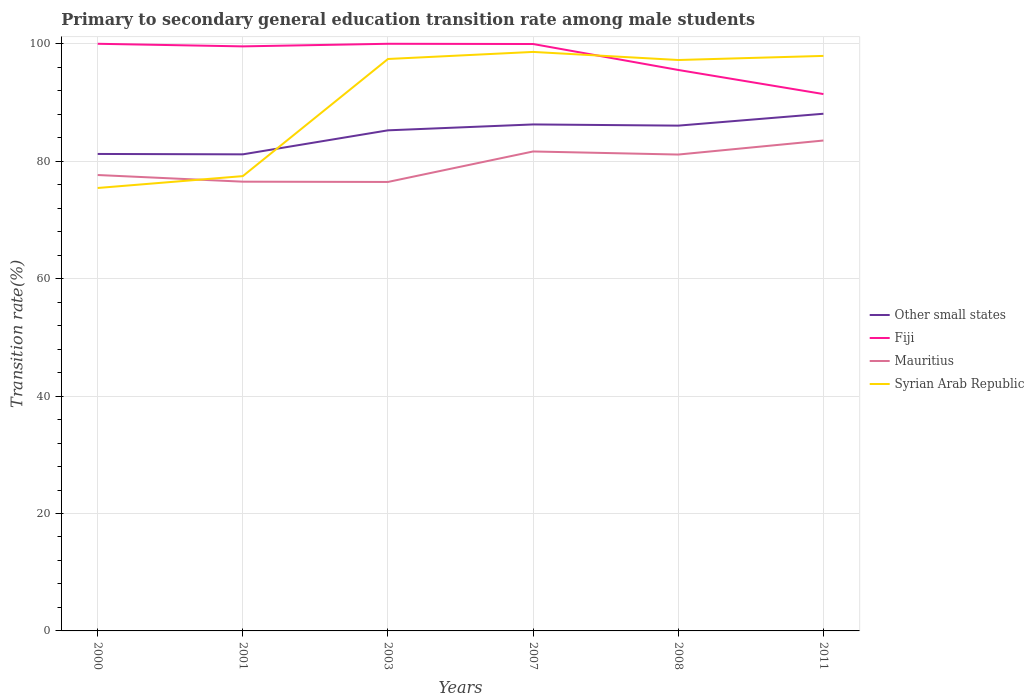How many different coloured lines are there?
Give a very brief answer. 4. Does the line corresponding to Fiji intersect with the line corresponding to Syrian Arab Republic?
Keep it short and to the point. Yes. Across all years, what is the maximum transition rate in Syrian Arab Republic?
Provide a short and direct response. 75.44. What is the difference between the highest and the second highest transition rate in Mauritius?
Keep it short and to the point. 7.06. What is the difference between the highest and the lowest transition rate in Syrian Arab Republic?
Provide a short and direct response. 4. How many lines are there?
Your answer should be compact. 4. What is the difference between two consecutive major ticks on the Y-axis?
Ensure brevity in your answer.  20. Are the values on the major ticks of Y-axis written in scientific E-notation?
Give a very brief answer. No. How many legend labels are there?
Your answer should be very brief. 4. How are the legend labels stacked?
Provide a succinct answer. Vertical. What is the title of the graph?
Your answer should be very brief. Primary to secondary general education transition rate among male students. What is the label or title of the X-axis?
Your answer should be very brief. Years. What is the label or title of the Y-axis?
Offer a very short reply. Transition rate(%). What is the Transition rate(%) of Other small states in 2000?
Offer a terse response. 81.24. What is the Transition rate(%) of Mauritius in 2000?
Your answer should be compact. 77.65. What is the Transition rate(%) in Syrian Arab Republic in 2000?
Offer a terse response. 75.44. What is the Transition rate(%) of Other small states in 2001?
Provide a short and direct response. 81.17. What is the Transition rate(%) in Fiji in 2001?
Provide a short and direct response. 99.56. What is the Transition rate(%) of Mauritius in 2001?
Make the answer very short. 76.51. What is the Transition rate(%) in Syrian Arab Republic in 2001?
Ensure brevity in your answer.  77.46. What is the Transition rate(%) in Other small states in 2003?
Make the answer very short. 85.26. What is the Transition rate(%) in Fiji in 2003?
Provide a short and direct response. 100. What is the Transition rate(%) of Mauritius in 2003?
Your answer should be very brief. 76.47. What is the Transition rate(%) in Syrian Arab Republic in 2003?
Your response must be concise. 97.41. What is the Transition rate(%) in Other small states in 2007?
Give a very brief answer. 86.26. What is the Transition rate(%) in Fiji in 2007?
Give a very brief answer. 99.96. What is the Transition rate(%) of Mauritius in 2007?
Your answer should be compact. 81.66. What is the Transition rate(%) in Syrian Arab Republic in 2007?
Give a very brief answer. 98.61. What is the Transition rate(%) of Other small states in 2008?
Provide a succinct answer. 86.06. What is the Transition rate(%) of Fiji in 2008?
Your answer should be very brief. 95.54. What is the Transition rate(%) of Mauritius in 2008?
Your answer should be compact. 81.13. What is the Transition rate(%) of Syrian Arab Republic in 2008?
Your answer should be compact. 97.24. What is the Transition rate(%) in Other small states in 2011?
Give a very brief answer. 88.09. What is the Transition rate(%) of Fiji in 2011?
Offer a very short reply. 91.44. What is the Transition rate(%) in Mauritius in 2011?
Your answer should be compact. 83.52. What is the Transition rate(%) in Syrian Arab Republic in 2011?
Give a very brief answer. 97.93. Across all years, what is the maximum Transition rate(%) in Other small states?
Provide a succinct answer. 88.09. Across all years, what is the maximum Transition rate(%) of Fiji?
Make the answer very short. 100. Across all years, what is the maximum Transition rate(%) in Mauritius?
Give a very brief answer. 83.52. Across all years, what is the maximum Transition rate(%) in Syrian Arab Republic?
Offer a very short reply. 98.61. Across all years, what is the minimum Transition rate(%) in Other small states?
Keep it short and to the point. 81.17. Across all years, what is the minimum Transition rate(%) in Fiji?
Keep it short and to the point. 91.44. Across all years, what is the minimum Transition rate(%) in Mauritius?
Provide a succinct answer. 76.47. Across all years, what is the minimum Transition rate(%) of Syrian Arab Republic?
Keep it short and to the point. 75.44. What is the total Transition rate(%) of Other small states in the graph?
Your answer should be very brief. 508.07. What is the total Transition rate(%) in Fiji in the graph?
Your answer should be very brief. 586.49. What is the total Transition rate(%) of Mauritius in the graph?
Your response must be concise. 476.95. What is the total Transition rate(%) in Syrian Arab Republic in the graph?
Offer a very short reply. 544.1. What is the difference between the Transition rate(%) of Other small states in 2000 and that in 2001?
Provide a short and direct response. 0.07. What is the difference between the Transition rate(%) in Fiji in 2000 and that in 2001?
Provide a succinct answer. 0.44. What is the difference between the Transition rate(%) in Mauritius in 2000 and that in 2001?
Your answer should be very brief. 1.14. What is the difference between the Transition rate(%) in Syrian Arab Republic in 2000 and that in 2001?
Offer a terse response. -2.02. What is the difference between the Transition rate(%) of Other small states in 2000 and that in 2003?
Give a very brief answer. -4.02. What is the difference between the Transition rate(%) in Mauritius in 2000 and that in 2003?
Your answer should be compact. 1.18. What is the difference between the Transition rate(%) of Syrian Arab Republic in 2000 and that in 2003?
Offer a very short reply. -21.97. What is the difference between the Transition rate(%) in Other small states in 2000 and that in 2007?
Offer a terse response. -5.03. What is the difference between the Transition rate(%) in Fiji in 2000 and that in 2007?
Your answer should be compact. 0.04. What is the difference between the Transition rate(%) in Mauritius in 2000 and that in 2007?
Provide a succinct answer. -4.01. What is the difference between the Transition rate(%) in Syrian Arab Republic in 2000 and that in 2007?
Offer a terse response. -23.17. What is the difference between the Transition rate(%) in Other small states in 2000 and that in 2008?
Make the answer very short. -4.82. What is the difference between the Transition rate(%) of Fiji in 2000 and that in 2008?
Offer a very short reply. 4.46. What is the difference between the Transition rate(%) of Mauritius in 2000 and that in 2008?
Your response must be concise. -3.48. What is the difference between the Transition rate(%) in Syrian Arab Republic in 2000 and that in 2008?
Your answer should be very brief. -21.8. What is the difference between the Transition rate(%) of Other small states in 2000 and that in 2011?
Provide a short and direct response. -6.85. What is the difference between the Transition rate(%) of Fiji in 2000 and that in 2011?
Keep it short and to the point. 8.56. What is the difference between the Transition rate(%) in Mauritius in 2000 and that in 2011?
Keep it short and to the point. -5.87. What is the difference between the Transition rate(%) in Syrian Arab Republic in 2000 and that in 2011?
Your response must be concise. -22.49. What is the difference between the Transition rate(%) of Other small states in 2001 and that in 2003?
Make the answer very short. -4.09. What is the difference between the Transition rate(%) of Fiji in 2001 and that in 2003?
Offer a terse response. -0.44. What is the difference between the Transition rate(%) of Mauritius in 2001 and that in 2003?
Provide a succinct answer. 0.05. What is the difference between the Transition rate(%) of Syrian Arab Republic in 2001 and that in 2003?
Your answer should be compact. -19.95. What is the difference between the Transition rate(%) in Other small states in 2001 and that in 2007?
Your answer should be compact. -5.09. What is the difference between the Transition rate(%) of Fiji in 2001 and that in 2007?
Provide a succinct answer. -0.4. What is the difference between the Transition rate(%) of Mauritius in 2001 and that in 2007?
Offer a terse response. -5.15. What is the difference between the Transition rate(%) of Syrian Arab Republic in 2001 and that in 2007?
Make the answer very short. -21.15. What is the difference between the Transition rate(%) in Other small states in 2001 and that in 2008?
Ensure brevity in your answer.  -4.89. What is the difference between the Transition rate(%) of Fiji in 2001 and that in 2008?
Keep it short and to the point. 4.02. What is the difference between the Transition rate(%) in Mauritius in 2001 and that in 2008?
Offer a very short reply. -4.62. What is the difference between the Transition rate(%) of Syrian Arab Republic in 2001 and that in 2008?
Keep it short and to the point. -19.78. What is the difference between the Transition rate(%) in Other small states in 2001 and that in 2011?
Ensure brevity in your answer.  -6.92. What is the difference between the Transition rate(%) of Fiji in 2001 and that in 2011?
Make the answer very short. 8.12. What is the difference between the Transition rate(%) of Mauritius in 2001 and that in 2011?
Your answer should be very brief. -7.01. What is the difference between the Transition rate(%) in Syrian Arab Republic in 2001 and that in 2011?
Offer a very short reply. -20.47. What is the difference between the Transition rate(%) of Other small states in 2003 and that in 2007?
Make the answer very short. -1. What is the difference between the Transition rate(%) in Fiji in 2003 and that in 2007?
Keep it short and to the point. 0.04. What is the difference between the Transition rate(%) of Mauritius in 2003 and that in 2007?
Ensure brevity in your answer.  -5.19. What is the difference between the Transition rate(%) in Syrian Arab Republic in 2003 and that in 2007?
Your answer should be very brief. -1.2. What is the difference between the Transition rate(%) of Other small states in 2003 and that in 2008?
Provide a succinct answer. -0.8. What is the difference between the Transition rate(%) in Fiji in 2003 and that in 2008?
Provide a short and direct response. 4.46. What is the difference between the Transition rate(%) in Mauritius in 2003 and that in 2008?
Offer a very short reply. -4.67. What is the difference between the Transition rate(%) in Syrian Arab Republic in 2003 and that in 2008?
Offer a very short reply. 0.17. What is the difference between the Transition rate(%) in Other small states in 2003 and that in 2011?
Provide a succinct answer. -2.82. What is the difference between the Transition rate(%) in Fiji in 2003 and that in 2011?
Provide a short and direct response. 8.56. What is the difference between the Transition rate(%) in Mauritius in 2003 and that in 2011?
Provide a short and direct response. -7.06. What is the difference between the Transition rate(%) in Syrian Arab Republic in 2003 and that in 2011?
Offer a very short reply. -0.52. What is the difference between the Transition rate(%) of Other small states in 2007 and that in 2008?
Give a very brief answer. 0.2. What is the difference between the Transition rate(%) of Fiji in 2007 and that in 2008?
Offer a terse response. 4.42. What is the difference between the Transition rate(%) in Mauritius in 2007 and that in 2008?
Ensure brevity in your answer.  0.53. What is the difference between the Transition rate(%) in Syrian Arab Republic in 2007 and that in 2008?
Make the answer very short. 1.38. What is the difference between the Transition rate(%) in Other small states in 2007 and that in 2011?
Provide a short and direct response. -1.82. What is the difference between the Transition rate(%) of Fiji in 2007 and that in 2011?
Your answer should be very brief. 8.52. What is the difference between the Transition rate(%) of Mauritius in 2007 and that in 2011?
Give a very brief answer. -1.86. What is the difference between the Transition rate(%) of Syrian Arab Republic in 2007 and that in 2011?
Keep it short and to the point. 0.68. What is the difference between the Transition rate(%) of Other small states in 2008 and that in 2011?
Provide a short and direct response. -2.02. What is the difference between the Transition rate(%) of Fiji in 2008 and that in 2011?
Keep it short and to the point. 4.1. What is the difference between the Transition rate(%) in Mauritius in 2008 and that in 2011?
Provide a succinct answer. -2.39. What is the difference between the Transition rate(%) in Syrian Arab Republic in 2008 and that in 2011?
Offer a very short reply. -0.7. What is the difference between the Transition rate(%) of Other small states in 2000 and the Transition rate(%) of Fiji in 2001?
Provide a succinct answer. -18.32. What is the difference between the Transition rate(%) in Other small states in 2000 and the Transition rate(%) in Mauritius in 2001?
Ensure brevity in your answer.  4.72. What is the difference between the Transition rate(%) in Other small states in 2000 and the Transition rate(%) in Syrian Arab Republic in 2001?
Your answer should be compact. 3.77. What is the difference between the Transition rate(%) of Fiji in 2000 and the Transition rate(%) of Mauritius in 2001?
Give a very brief answer. 23.49. What is the difference between the Transition rate(%) in Fiji in 2000 and the Transition rate(%) in Syrian Arab Republic in 2001?
Offer a very short reply. 22.54. What is the difference between the Transition rate(%) in Mauritius in 2000 and the Transition rate(%) in Syrian Arab Republic in 2001?
Offer a very short reply. 0.19. What is the difference between the Transition rate(%) of Other small states in 2000 and the Transition rate(%) of Fiji in 2003?
Make the answer very short. -18.76. What is the difference between the Transition rate(%) of Other small states in 2000 and the Transition rate(%) of Mauritius in 2003?
Make the answer very short. 4.77. What is the difference between the Transition rate(%) of Other small states in 2000 and the Transition rate(%) of Syrian Arab Republic in 2003?
Keep it short and to the point. -16.17. What is the difference between the Transition rate(%) in Fiji in 2000 and the Transition rate(%) in Mauritius in 2003?
Make the answer very short. 23.53. What is the difference between the Transition rate(%) of Fiji in 2000 and the Transition rate(%) of Syrian Arab Republic in 2003?
Provide a short and direct response. 2.59. What is the difference between the Transition rate(%) in Mauritius in 2000 and the Transition rate(%) in Syrian Arab Republic in 2003?
Provide a short and direct response. -19.76. What is the difference between the Transition rate(%) in Other small states in 2000 and the Transition rate(%) in Fiji in 2007?
Your response must be concise. -18.72. What is the difference between the Transition rate(%) in Other small states in 2000 and the Transition rate(%) in Mauritius in 2007?
Keep it short and to the point. -0.42. What is the difference between the Transition rate(%) in Other small states in 2000 and the Transition rate(%) in Syrian Arab Republic in 2007?
Ensure brevity in your answer.  -17.38. What is the difference between the Transition rate(%) in Fiji in 2000 and the Transition rate(%) in Mauritius in 2007?
Ensure brevity in your answer.  18.34. What is the difference between the Transition rate(%) of Fiji in 2000 and the Transition rate(%) of Syrian Arab Republic in 2007?
Ensure brevity in your answer.  1.39. What is the difference between the Transition rate(%) in Mauritius in 2000 and the Transition rate(%) in Syrian Arab Republic in 2007?
Give a very brief answer. -20.96. What is the difference between the Transition rate(%) of Other small states in 2000 and the Transition rate(%) of Fiji in 2008?
Your response must be concise. -14.3. What is the difference between the Transition rate(%) of Other small states in 2000 and the Transition rate(%) of Mauritius in 2008?
Give a very brief answer. 0.1. What is the difference between the Transition rate(%) of Other small states in 2000 and the Transition rate(%) of Syrian Arab Republic in 2008?
Give a very brief answer. -16. What is the difference between the Transition rate(%) in Fiji in 2000 and the Transition rate(%) in Mauritius in 2008?
Ensure brevity in your answer.  18.87. What is the difference between the Transition rate(%) in Fiji in 2000 and the Transition rate(%) in Syrian Arab Republic in 2008?
Your response must be concise. 2.76. What is the difference between the Transition rate(%) in Mauritius in 2000 and the Transition rate(%) in Syrian Arab Republic in 2008?
Provide a succinct answer. -19.59. What is the difference between the Transition rate(%) of Other small states in 2000 and the Transition rate(%) of Fiji in 2011?
Your answer should be compact. -10.2. What is the difference between the Transition rate(%) in Other small states in 2000 and the Transition rate(%) in Mauritius in 2011?
Provide a short and direct response. -2.29. What is the difference between the Transition rate(%) in Other small states in 2000 and the Transition rate(%) in Syrian Arab Republic in 2011?
Your answer should be compact. -16.7. What is the difference between the Transition rate(%) in Fiji in 2000 and the Transition rate(%) in Mauritius in 2011?
Offer a very short reply. 16.48. What is the difference between the Transition rate(%) in Fiji in 2000 and the Transition rate(%) in Syrian Arab Republic in 2011?
Ensure brevity in your answer.  2.07. What is the difference between the Transition rate(%) of Mauritius in 2000 and the Transition rate(%) of Syrian Arab Republic in 2011?
Your answer should be compact. -20.29. What is the difference between the Transition rate(%) in Other small states in 2001 and the Transition rate(%) in Fiji in 2003?
Offer a very short reply. -18.83. What is the difference between the Transition rate(%) of Other small states in 2001 and the Transition rate(%) of Mauritius in 2003?
Provide a short and direct response. 4.7. What is the difference between the Transition rate(%) of Other small states in 2001 and the Transition rate(%) of Syrian Arab Republic in 2003?
Provide a succinct answer. -16.24. What is the difference between the Transition rate(%) of Fiji in 2001 and the Transition rate(%) of Mauritius in 2003?
Your answer should be compact. 23.09. What is the difference between the Transition rate(%) in Fiji in 2001 and the Transition rate(%) in Syrian Arab Republic in 2003?
Ensure brevity in your answer.  2.15. What is the difference between the Transition rate(%) of Mauritius in 2001 and the Transition rate(%) of Syrian Arab Republic in 2003?
Provide a short and direct response. -20.9. What is the difference between the Transition rate(%) in Other small states in 2001 and the Transition rate(%) in Fiji in 2007?
Ensure brevity in your answer.  -18.79. What is the difference between the Transition rate(%) of Other small states in 2001 and the Transition rate(%) of Mauritius in 2007?
Your answer should be very brief. -0.49. What is the difference between the Transition rate(%) of Other small states in 2001 and the Transition rate(%) of Syrian Arab Republic in 2007?
Offer a very short reply. -17.45. What is the difference between the Transition rate(%) in Fiji in 2001 and the Transition rate(%) in Mauritius in 2007?
Provide a succinct answer. 17.9. What is the difference between the Transition rate(%) in Fiji in 2001 and the Transition rate(%) in Syrian Arab Republic in 2007?
Provide a short and direct response. 0.94. What is the difference between the Transition rate(%) in Mauritius in 2001 and the Transition rate(%) in Syrian Arab Republic in 2007?
Ensure brevity in your answer.  -22.1. What is the difference between the Transition rate(%) of Other small states in 2001 and the Transition rate(%) of Fiji in 2008?
Offer a terse response. -14.37. What is the difference between the Transition rate(%) in Other small states in 2001 and the Transition rate(%) in Mauritius in 2008?
Ensure brevity in your answer.  0.04. What is the difference between the Transition rate(%) in Other small states in 2001 and the Transition rate(%) in Syrian Arab Republic in 2008?
Keep it short and to the point. -16.07. What is the difference between the Transition rate(%) of Fiji in 2001 and the Transition rate(%) of Mauritius in 2008?
Make the answer very short. 18.42. What is the difference between the Transition rate(%) of Fiji in 2001 and the Transition rate(%) of Syrian Arab Republic in 2008?
Keep it short and to the point. 2.32. What is the difference between the Transition rate(%) in Mauritius in 2001 and the Transition rate(%) in Syrian Arab Republic in 2008?
Provide a short and direct response. -20.72. What is the difference between the Transition rate(%) of Other small states in 2001 and the Transition rate(%) of Fiji in 2011?
Give a very brief answer. -10.27. What is the difference between the Transition rate(%) in Other small states in 2001 and the Transition rate(%) in Mauritius in 2011?
Your response must be concise. -2.35. What is the difference between the Transition rate(%) of Other small states in 2001 and the Transition rate(%) of Syrian Arab Republic in 2011?
Provide a succinct answer. -16.77. What is the difference between the Transition rate(%) in Fiji in 2001 and the Transition rate(%) in Mauritius in 2011?
Ensure brevity in your answer.  16.03. What is the difference between the Transition rate(%) in Fiji in 2001 and the Transition rate(%) in Syrian Arab Republic in 2011?
Provide a succinct answer. 1.62. What is the difference between the Transition rate(%) in Mauritius in 2001 and the Transition rate(%) in Syrian Arab Republic in 2011?
Offer a very short reply. -21.42. What is the difference between the Transition rate(%) in Other small states in 2003 and the Transition rate(%) in Fiji in 2007?
Your response must be concise. -14.7. What is the difference between the Transition rate(%) in Other small states in 2003 and the Transition rate(%) in Mauritius in 2007?
Your answer should be compact. 3.6. What is the difference between the Transition rate(%) in Other small states in 2003 and the Transition rate(%) in Syrian Arab Republic in 2007?
Give a very brief answer. -13.35. What is the difference between the Transition rate(%) in Fiji in 2003 and the Transition rate(%) in Mauritius in 2007?
Provide a short and direct response. 18.34. What is the difference between the Transition rate(%) in Fiji in 2003 and the Transition rate(%) in Syrian Arab Republic in 2007?
Your answer should be very brief. 1.39. What is the difference between the Transition rate(%) of Mauritius in 2003 and the Transition rate(%) of Syrian Arab Republic in 2007?
Make the answer very short. -22.15. What is the difference between the Transition rate(%) in Other small states in 2003 and the Transition rate(%) in Fiji in 2008?
Provide a short and direct response. -10.28. What is the difference between the Transition rate(%) of Other small states in 2003 and the Transition rate(%) of Mauritius in 2008?
Offer a terse response. 4.13. What is the difference between the Transition rate(%) of Other small states in 2003 and the Transition rate(%) of Syrian Arab Republic in 2008?
Provide a short and direct response. -11.98. What is the difference between the Transition rate(%) in Fiji in 2003 and the Transition rate(%) in Mauritius in 2008?
Ensure brevity in your answer.  18.87. What is the difference between the Transition rate(%) in Fiji in 2003 and the Transition rate(%) in Syrian Arab Republic in 2008?
Provide a short and direct response. 2.76. What is the difference between the Transition rate(%) of Mauritius in 2003 and the Transition rate(%) of Syrian Arab Republic in 2008?
Keep it short and to the point. -20.77. What is the difference between the Transition rate(%) in Other small states in 2003 and the Transition rate(%) in Fiji in 2011?
Provide a succinct answer. -6.18. What is the difference between the Transition rate(%) of Other small states in 2003 and the Transition rate(%) of Mauritius in 2011?
Give a very brief answer. 1.74. What is the difference between the Transition rate(%) of Other small states in 2003 and the Transition rate(%) of Syrian Arab Republic in 2011?
Keep it short and to the point. -12.67. What is the difference between the Transition rate(%) in Fiji in 2003 and the Transition rate(%) in Mauritius in 2011?
Make the answer very short. 16.48. What is the difference between the Transition rate(%) of Fiji in 2003 and the Transition rate(%) of Syrian Arab Republic in 2011?
Ensure brevity in your answer.  2.07. What is the difference between the Transition rate(%) of Mauritius in 2003 and the Transition rate(%) of Syrian Arab Republic in 2011?
Make the answer very short. -21.47. What is the difference between the Transition rate(%) in Other small states in 2007 and the Transition rate(%) in Fiji in 2008?
Your answer should be very brief. -9.28. What is the difference between the Transition rate(%) in Other small states in 2007 and the Transition rate(%) in Mauritius in 2008?
Provide a succinct answer. 5.13. What is the difference between the Transition rate(%) in Other small states in 2007 and the Transition rate(%) in Syrian Arab Republic in 2008?
Make the answer very short. -10.98. What is the difference between the Transition rate(%) of Fiji in 2007 and the Transition rate(%) of Mauritius in 2008?
Make the answer very short. 18.83. What is the difference between the Transition rate(%) of Fiji in 2007 and the Transition rate(%) of Syrian Arab Republic in 2008?
Provide a short and direct response. 2.72. What is the difference between the Transition rate(%) in Mauritius in 2007 and the Transition rate(%) in Syrian Arab Republic in 2008?
Ensure brevity in your answer.  -15.58. What is the difference between the Transition rate(%) in Other small states in 2007 and the Transition rate(%) in Fiji in 2011?
Ensure brevity in your answer.  -5.17. What is the difference between the Transition rate(%) in Other small states in 2007 and the Transition rate(%) in Mauritius in 2011?
Offer a very short reply. 2.74. What is the difference between the Transition rate(%) of Other small states in 2007 and the Transition rate(%) of Syrian Arab Republic in 2011?
Ensure brevity in your answer.  -11.67. What is the difference between the Transition rate(%) of Fiji in 2007 and the Transition rate(%) of Mauritius in 2011?
Keep it short and to the point. 16.44. What is the difference between the Transition rate(%) of Fiji in 2007 and the Transition rate(%) of Syrian Arab Republic in 2011?
Provide a succinct answer. 2.03. What is the difference between the Transition rate(%) in Mauritius in 2007 and the Transition rate(%) in Syrian Arab Republic in 2011?
Offer a terse response. -16.27. What is the difference between the Transition rate(%) of Other small states in 2008 and the Transition rate(%) of Fiji in 2011?
Keep it short and to the point. -5.38. What is the difference between the Transition rate(%) of Other small states in 2008 and the Transition rate(%) of Mauritius in 2011?
Offer a terse response. 2.54. What is the difference between the Transition rate(%) of Other small states in 2008 and the Transition rate(%) of Syrian Arab Republic in 2011?
Provide a succinct answer. -11.87. What is the difference between the Transition rate(%) of Fiji in 2008 and the Transition rate(%) of Mauritius in 2011?
Your answer should be compact. 12.02. What is the difference between the Transition rate(%) in Fiji in 2008 and the Transition rate(%) in Syrian Arab Republic in 2011?
Offer a very short reply. -2.39. What is the difference between the Transition rate(%) of Mauritius in 2008 and the Transition rate(%) of Syrian Arab Republic in 2011?
Offer a terse response. -16.8. What is the average Transition rate(%) in Other small states per year?
Give a very brief answer. 84.68. What is the average Transition rate(%) in Fiji per year?
Your response must be concise. 97.75. What is the average Transition rate(%) in Mauritius per year?
Keep it short and to the point. 79.49. What is the average Transition rate(%) in Syrian Arab Republic per year?
Your response must be concise. 90.68. In the year 2000, what is the difference between the Transition rate(%) in Other small states and Transition rate(%) in Fiji?
Provide a succinct answer. -18.76. In the year 2000, what is the difference between the Transition rate(%) of Other small states and Transition rate(%) of Mauritius?
Provide a short and direct response. 3.59. In the year 2000, what is the difference between the Transition rate(%) of Other small states and Transition rate(%) of Syrian Arab Republic?
Keep it short and to the point. 5.8. In the year 2000, what is the difference between the Transition rate(%) of Fiji and Transition rate(%) of Mauritius?
Offer a very short reply. 22.35. In the year 2000, what is the difference between the Transition rate(%) in Fiji and Transition rate(%) in Syrian Arab Republic?
Your answer should be compact. 24.56. In the year 2000, what is the difference between the Transition rate(%) in Mauritius and Transition rate(%) in Syrian Arab Republic?
Ensure brevity in your answer.  2.21. In the year 2001, what is the difference between the Transition rate(%) in Other small states and Transition rate(%) in Fiji?
Keep it short and to the point. -18.39. In the year 2001, what is the difference between the Transition rate(%) in Other small states and Transition rate(%) in Mauritius?
Keep it short and to the point. 4.65. In the year 2001, what is the difference between the Transition rate(%) of Other small states and Transition rate(%) of Syrian Arab Republic?
Provide a succinct answer. 3.71. In the year 2001, what is the difference between the Transition rate(%) of Fiji and Transition rate(%) of Mauritius?
Provide a succinct answer. 23.04. In the year 2001, what is the difference between the Transition rate(%) in Fiji and Transition rate(%) in Syrian Arab Republic?
Give a very brief answer. 22.1. In the year 2001, what is the difference between the Transition rate(%) of Mauritius and Transition rate(%) of Syrian Arab Republic?
Offer a terse response. -0.95. In the year 2003, what is the difference between the Transition rate(%) of Other small states and Transition rate(%) of Fiji?
Give a very brief answer. -14.74. In the year 2003, what is the difference between the Transition rate(%) in Other small states and Transition rate(%) in Mauritius?
Keep it short and to the point. 8.79. In the year 2003, what is the difference between the Transition rate(%) in Other small states and Transition rate(%) in Syrian Arab Republic?
Make the answer very short. -12.15. In the year 2003, what is the difference between the Transition rate(%) in Fiji and Transition rate(%) in Mauritius?
Your response must be concise. 23.53. In the year 2003, what is the difference between the Transition rate(%) in Fiji and Transition rate(%) in Syrian Arab Republic?
Offer a very short reply. 2.59. In the year 2003, what is the difference between the Transition rate(%) of Mauritius and Transition rate(%) of Syrian Arab Republic?
Provide a short and direct response. -20.94. In the year 2007, what is the difference between the Transition rate(%) in Other small states and Transition rate(%) in Fiji?
Your response must be concise. -13.7. In the year 2007, what is the difference between the Transition rate(%) of Other small states and Transition rate(%) of Mauritius?
Ensure brevity in your answer.  4.6. In the year 2007, what is the difference between the Transition rate(%) of Other small states and Transition rate(%) of Syrian Arab Republic?
Offer a very short reply. -12.35. In the year 2007, what is the difference between the Transition rate(%) of Fiji and Transition rate(%) of Mauritius?
Provide a short and direct response. 18.3. In the year 2007, what is the difference between the Transition rate(%) of Fiji and Transition rate(%) of Syrian Arab Republic?
Provide a succinct answer. 1.35. In the year 2007, what is the difference between the Transition rate(%) of Mauritius and Transition rate(%) of Syrian Arab Republic?
Your response must be concise. -16.95. In the year 2008, what is the difference between the Transition rate(%) of Other small states and Transition rate(%) of Fiji?
Make the answer very short. -9.48. In the year 2008, what is the difference between the Transition rate(%) of Other small states and Transition rate(%) of Mauritius?
Provide a succinct answer. 4.93. In the year 2008, what is the difference between the Transition rate(%) of Other small states and Transition rate(%) of Syrian Arab Republic?
Your answer should be very brief. -11.18. In the year 2008, what is the difference between the Transition rate(%) in Fiji and Transition rate(%) in Mauritius?
Your answer should be very brief. 14.41. In the year 2008, what is the difference between the Transition rate(%) of Fiji and Transition rate(%) of Syrian Arab Republic?
Make the answer very short. -1.7. In the year 2008, what is the difference between the Transition rate(%) in Mauritius and Transition rate(%) in Syrian Arab Republic?
Your answer should be very brief. -16.1. In the year 2011, what is the difference between the Transition rate(%) of Other small states and Transition rate(%) of Fiji?
Provide a succinct answer. -3.35. In the year 2011, what is the difference between the Transition rate(%) in Other small states and Transition rate(%) in Mauritius?
Make the answer very short. 4.56. In the year 2011, what is the difference between the Transition rate(%) in Other small states and Transition rate(%) in Syrian Arab Republic?
Ensure brevity in your answer.  -9.85. In the year 2011, what is the difference between the Transition rate(%) in Fiji and Transition rate(%) in Mauritius?
Your answer should be very brief. 7.91. In the year 2011, what is the difference between the Transition rate(%) in Fiji and Transition rate(%) in Syrian Arab Republic?
Your response must be concise. -6.5. In the year 2011, what is the difference between the Transition rate(%) in Mauritius and Transition rate(%) in Syrian Arab Republic?
Ensure brevity in your answer.  -14.41. What is the ratio of the Transition rate(%) in Fiji in 2000 to that in 2001?
Make the answer very short. 1. What is the ratio of the Transition rate(%) in Mauritius in 2000 to that in 2001?
Keep it short and to the point. 1.01. What is the ratio of the Transition rate(%) of Syrian Arab Republic in 2000 to that in 2001?
Your response must be concise. 0.97. What is the ratio of the Transition rate(%) in Other small states in 2000 to that in 2003?
Make the answer very short. 0.95. What is the ratio of the Transition rate(%) of Fiji in 2000 to that in 2003?
Ensure brevity in your answer.  1. What is the ratio of the Transition rate(%) of Mauritius in 2000 to that in 2003?
Offer a terse response. 1.02. What is the ratio of the Transition rate(%) of Syrian Arab Republic in 2000 to that in 2003?
Offer a very short reply. 0.77. What is the ratio of the Transition rate(%) of Other small states in 2000 to that in 2007?
Offer a very short reply. 0.94. What is the ratio of the Transition rate(%) in Fiji in 2000 to that in 2007?
Ensure brevity in your answer.  1. What is the ratio of the Transition rate(%) of Mauritius in 2000 to that in 2007?
Your answer should be compact. 0.95. What is the ratio of the Transition rate(%) of Syrian Arab Republic in 2000 to that in 2007?
Offer a terse response. 0.77. What is the ratio of the Transition rate(%) of Other small states in 2000 to that in 2008?
Give a very brief answer. 0.94. What is the ratio of the Transition rate(%) in Fiji in 2000 to that in 2008?
Make the answer very short. 1.05. What is the ratio of the Transition rate(%) in Mauritius in 2000 to that in 2008?
Keep it short and to the point. 0.96. What is the ratio of the Transition rate(%) in Syrian Arab Republic in 2000 to that in 2008?
Offer a very short reply. 0.78. What is the ratio of the Transition rate(%) in Other small states in 2000 to that in 2011?
Keep it short and to the point. 0.92. What is the ratio of the Transition rate(%) in Fiji in 2000 to that in 2011?
Make the answer very short. 1.09. What is the ratio of the Transition rate(%) in Mauritius in 2000 to that in 2011?
Provide a succinct answer. 0.93. What is the ratio of the Transition rate(%) of Syrian Arab Republic in 2000 to that in 2011?
Make the answer very short. 0.77. What is the ratio of the Transition rate(%) of Other small states in 2001 to that in 2003?
Offer a terse response. 0.95. What is the ratio of the Transition rate(%) in Fiji in 2001 to that in 2003?
Keep it short and to the point. 1. What is the ratio of the Transition rate(%) of Mauritius in 2001 to that in 2003?
Your answer should be very brief. 1. What is the ratio of the Transition rate(%) in Syrian Arab Republic in 2001 to that in 2003?
Ensure brevity in your answer.  0.8. What is the ratio of the Transition rate(%) in Other small states in 2001 to that in 2007?
Provide a short and direct response. 0.94. What is the ratio of the Transition rate(%) of Fiji in 2001 to that in 2007?
Give a very brief answer. 1. What is the ratio of the Transition rate(%) in Mauritius in 2001 to that in 2007?
Ensure brevity in your answer.  0.94. What is the ratio of the Transition rate(%) in Syrian Arab Republic in 2001 to that in 2007?
Provide a succinct answer. 0.79. What is the ratio of the Transition rate(%) in Other small states in 2001 to that in 2008?
Your answer should be very brief. 0.94. What is the ratio of the Transition rate(%) in Fiji in 2001 to that in 2008?
Your answer should be very brief. 1.04. What is the ratio of the Transition rate(%) in Mauritius in 2001 to that in 2008?
Offer a very short reply. 0.94. What is the ratio of the Transition rate(%) in Syrian Arab Republic in 2001 to that in 2008?
Provide a short and direct response. 0.8. What is the ratio of the Transition rate(%) of Other small states in 2001 to that in 2011?
Your response must be concise. 0.92. What is the ratio of the Transition rate(%) of Fiji in 2001 to that in 2011?
Ensure brevity in your answer.  1.09. What is the ratio of the Transition rate(%) of Mauritius in 2001 to that in 2011?
Provide a succinct answer. 0.92. What is the ratio of the Transition rate(%) of Syrian Arab Republic in 2001 to that in 2011?
Your answer should be very brief. 0.79. What is the ratio of the Transition rate(%) in Other small states in 2003 to that in 2007?
Your response must be concise. 0.99. What is the ratio of the Transition rate(%) in Mauritius in 2003 to that in 2007?
Make the answer very short. 0.94. What is the ratio of the Transition rate(%) of Other small states in 2003 to that in 2008?
Ensure brevity in your answer.  0.99. What is the ratio of the Transition rate(%) of Fiji in 2003 to that in 2008?
Your response must be concise. 1.05. What is the ratio of the Transition rate(%) in Mauritius in 2003 to that in 2008?
Keep it short and to the point. 0.94. What is the ratio of the Transition rate(%) in Other small states in 2003 to that in 2011?
Your answer should be very brief. 0.97. What is the ratio of the Transition rate(%) in Fiji in 2003 to that in 2011?
Give a very brief answer. 1.09. What is the ratio of the Transition rate(%) in Mauritius in 2003 to that in 2011?
Provide a short and direct response. 0.92. What is the ratio of the Transition rate(%) of Other small states in 2007 to that in 2008?
Ensure brevity in your answer.  1. What is the ratio of the Transition rate(%) of Fiji in 2007 to that in 2008?
Your answer should be very brief. 1.05. What is the ratio of the Transition rate(%) in Syrian Arab Republic in 2007 to that in 2008?
Your answer should be very brief. 1.01. What is the ratio of the Transition rate(%) of Other small states in 2007 to that in 2011?
Your response must be concise. 0.98. What is the ratio of the Transition rate(%) of Fiji in 2007 to that in 2011?
Ensure brevity in your answer.  1.09. What is the ratio of the Transition rate(%) of Mauritius in 2007 to that in 2011?
Offer a very short reply. 0.98. What is the ratio of the Transition rate(%) in Fiji in 2008 to that in 2011?
Offer a terse response. 1.04. What is the ratio of the Transition rate(%) in Mauritius in 2008 to that in 2011?
Your answer should be very brief. 0.97. What is the ratio of the Transition rate(%) of Syrian Arab Republic in 2008 to that in 2011?
Ensure brevity in your answer.  0.99. What is the difference between the highest and the second highest Transition rate(%) of Other small states?
Ensure brevity in your answer.  1.82. What is the difference between the highest and the second highest Transition rate(%) in Fiji?
Your answer should be compact. 0. What is the difference between the highest and the second highest Transition rate(%) of Mauritius?
Your answer should be compact. 1.86. What is the difference between the highest and the second highest Transition rate(%) in Syrian Arab Republic?
Make the answer very short. 0.68. What is the difference between the highest and the lowest Transition rate(%) of Other small states?
Provide a short and direct response. 6.92. What is the difference between the highest and the lowest Transition rate(%) of Fiji?
Your answer should be compact. 8.56. What is the difference between the highest and the lowest Transition rate(%) of Mauritius?
Make the answer very short. 7.06. What is the difference between the highest and the lowest Transition rate(%) of Syrian Arab Republic?
Provide a short and direct response. 23.17. 